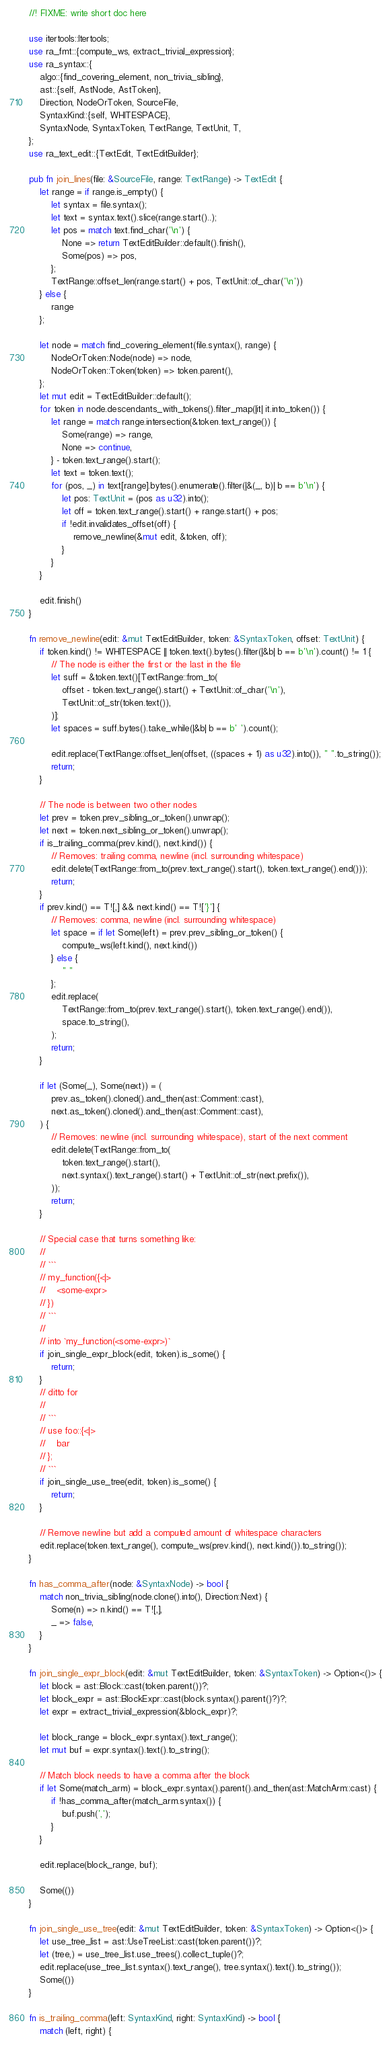Convert code to text. <code><loc_0><loc_0><loc_500><loc_500><_Rust_>//! FIXME: write short doc here

use itertools::Itertools;
use ra_fmt::{compute_ws, extract_trivial_expression};
use ra_syntax::{
    algo::{find_covering_element, non_trivia_sibling},
    ast::{self, AstNode, AstToken},
    Direction, NodeOrToken, SourceFile,
    SyntaxKind::{self, WHITESPACE},
    SyntaxNode, SyntaxToken, TextRange, TextUnit, T,
};
use ra_text_edit::{TextEdit, TextEditBuilder};

pub fn join_lines(file: &SourceFile, range: TextRange) -> TextEdit {
    let range = if range.is_empty() {
        let syntax = file.syntax();
        let text = syntax.text().slice(range.start()..);
        let pos = match text.find_char('\n') {
            None => return TextEditBuilder::default().finish(),
            Some(pos) => pos,
        };
        TextRange::offset_len(range.start() + pos, TextUnit::of_char('\n'))
    } else {
        range
    };

    let node = match find_covering_element(file.syntax(), range) {
        NodeOrToken::Node(node) => node,
        NodeOrToken::Token(token) => token.parent(),
    };
    let mut edit = TextEditBuilder::default();
    for token in node.descendants_with_tokens().filter_map(|it| it.into_token()) {
        let range = match range.intersection(&token.text_range()) {
            Some(range) => range,
            None => continue,
        } - token.text_range().start();
        let text = token.text();
        for (pos, _) in text[range].bytes().enumerate().filter(|&(_, b)| b == b'\n') {
            let pos: TextUnit = (pos as u32).into();
            let off = token.text_range().start() + range.start() + pos;
            if !edit.invalidates_offset(off) {
                remove_newline(&mut edit, &token, off);
            }
        }
    }

    edit.finish()
}

fn remove_newline(edit: &mut TextEditBuilder, token: &SyntaxToken, offset: TextUnit) {
    if token.kind() != WHITESPACE || token.text().bytes().filter(|&b| b == b'\n').count() != 1 {
        // The node is either the first or the last in the file
        let suff = &token.text()[TextRange::from_to(
            offset - token.text_range().start() + TextUnit::of_char('\n'),
            TextUnit::of_str(token.text()),
        )];
        let spaces = suff.bytes().take_while(|&b| b == b' ').count();

        edit.replace(TextRange::offset_len(offset, ((spaces + 1) as u32).into()), " ".to_string());
        return;
    }

    // The node is between two other nodes
    let prev = token.prev_sibling_or_token().unwrap();
    let next = token.next_sibling_or_token().unwrap();
    if is_trailing_comma(prev.kind(), next.kind()) {
        // Removes: trailing comma, newline (incl. surrounding whitespace)
        edit.delete(TextRange::from_to(prev.text_range().start(), token.text_range().end()));
        return;
    }
    if prev.kind() == T![,] && next.kind() == T!['}'] {
        // Removes: comma, newline (incl. surrounding whitespace)
        let space = if let Some(left) = prev.prev_sibling_or_token() {
            compute_ws(left.kind(), next.kind())
        } else {
            " "
        };
        edit.replace(
            TextRange::from_to(prev.text_range().start(), token.text_range().end()),
            space.to_string(),
        );
        return;
    }

    if let (Some(_), Some(next)) = (
        prev.as_token().cloned().and_then(ast::Comment::cast),
        next.as_token().cloned().and_then(ast::Comment::cast),
    ) {
        // Removes: newline (incl. surrounding whitespace), start of the next comment
        edit.delete(TextRange::from_to(
            token.text_range().start(),
            next.syntax().text_range().start() + TextUnit::of_str(next.prefix()),
        ));
        return;
    }

    // Special case that turns something like:
    //
    // ```
    // my_function({<|>
    //    <some-expr>
    // })
    // ```
    //
    // into `my_function(<some-expr>)`
    if join_single_expr_block(edit, token).is_some() {
        return;
    }
    // ditto for
    //
    // ```
    // use foo::{<|>
    //    bar
    // };
    // ```
    if join_single_use_tree(edit, token).is_some() {
        return;
    }

    // Remove newline but add a computed amount of whitespace characters
    edit.replace(token.text_range(), compute_ws(prev.kind(), next.kind()).to_string());
}

fn has_comma_after(node: &SyntaxNode) -> bool {
    match non_trivia_sibling(node.clone().into(), Direction::Next) {
        Some(n) => n.kind() == T![,],
        _ => false,
    }
}

fn join_single_expr_block(edit: &mut TextEditBuilder, token: &SyntaxToken) -> Option<()> {
    let block = ast::Block::cast(token.parent())?;
    let block_expr = ast::BlockExpr::cast(block.syntax().parent()?)?;
    let expr = extract_trivial_expression(&block_expr)?;

    let block_range = block_expr.syntax().text_range();
    let mut buf = expr.syntax().text().to_string();

    // Match block needs to have a comma after the block
    if let Some(match_arm) = block_expr.syntax().parent().and_then(ast::MatchArm::cast) {
        if !has_comma_after(match_arm.syntax()) {
            buf.push(',');
        }
    }

    edit.replace(block_range, buf);

    Some(())
}

fn join_single_use_tree(edit: &mut TextEditBuilder, token: &SyntaxToken) -> Option<()> {
    let use_tree_list = ast::UseTreeList::cast(token.parent())?;
    let (tree,) = use_tree_list.use_trees().collect_tuple()?;
    edit.replace(use_tree_list.syntax().text_range(), tree.syntax().text().to_string());
    Some(())
}

fn is_trailing_comma(left: SyntaxKind, right: SyntaxKind) -> bool {
    match (left, right) {</code> 